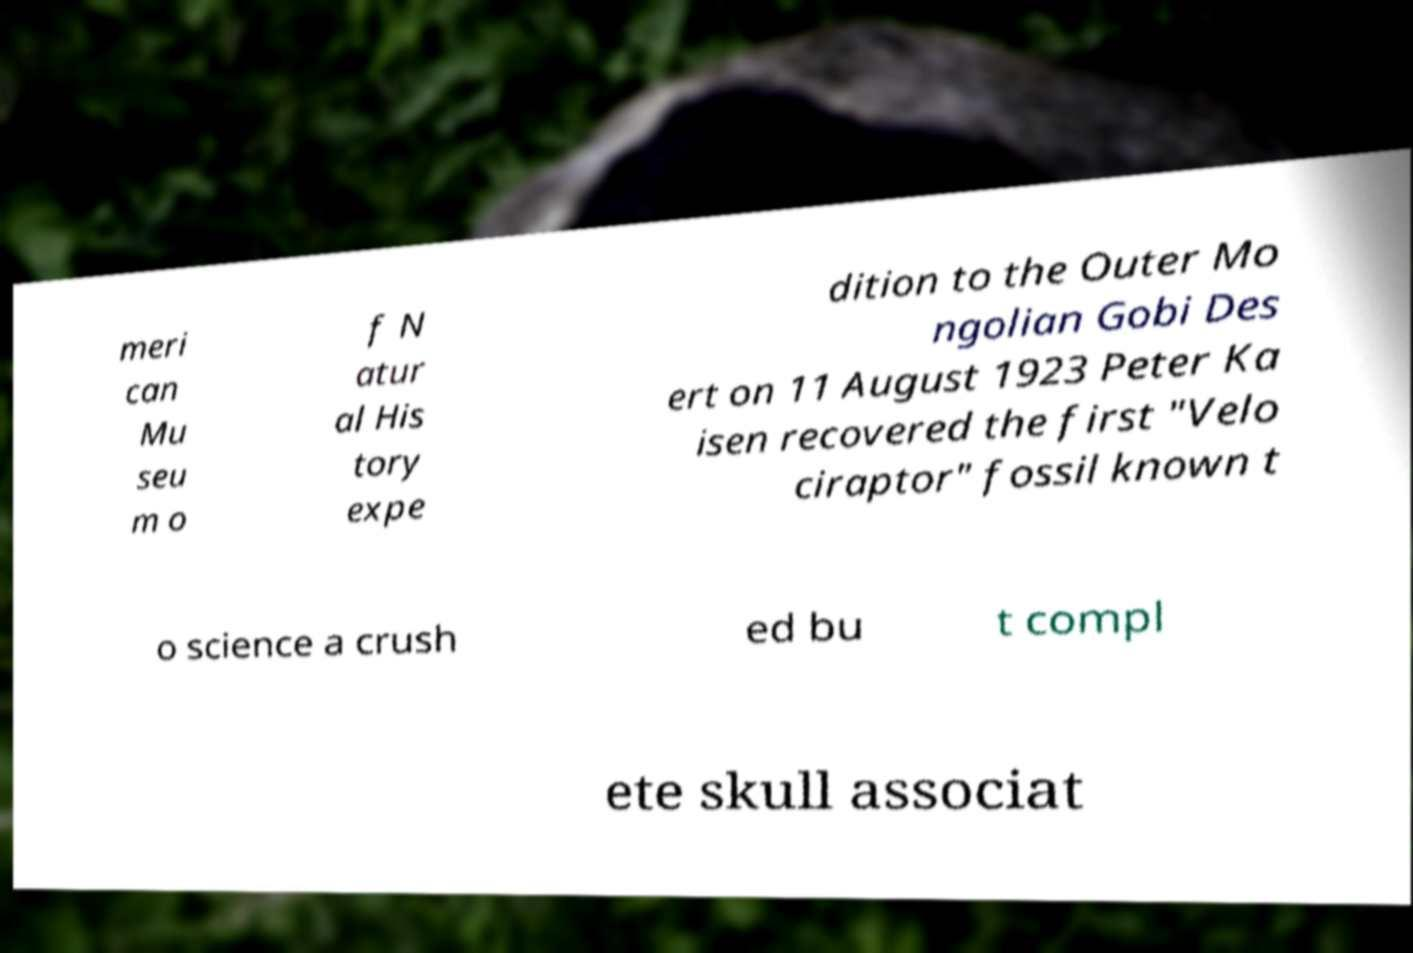I need the written content from this picture converted into text. Can you do that? meri can Mu seu m o f N atur al His tory expe dition to the Outer Mo ngolian Gobi Des ert on 11 August 1923 Peter Ka isen recovered the first "Velo ciraptor" fossil known t o science a crush ed bu t compl ete skull associat 